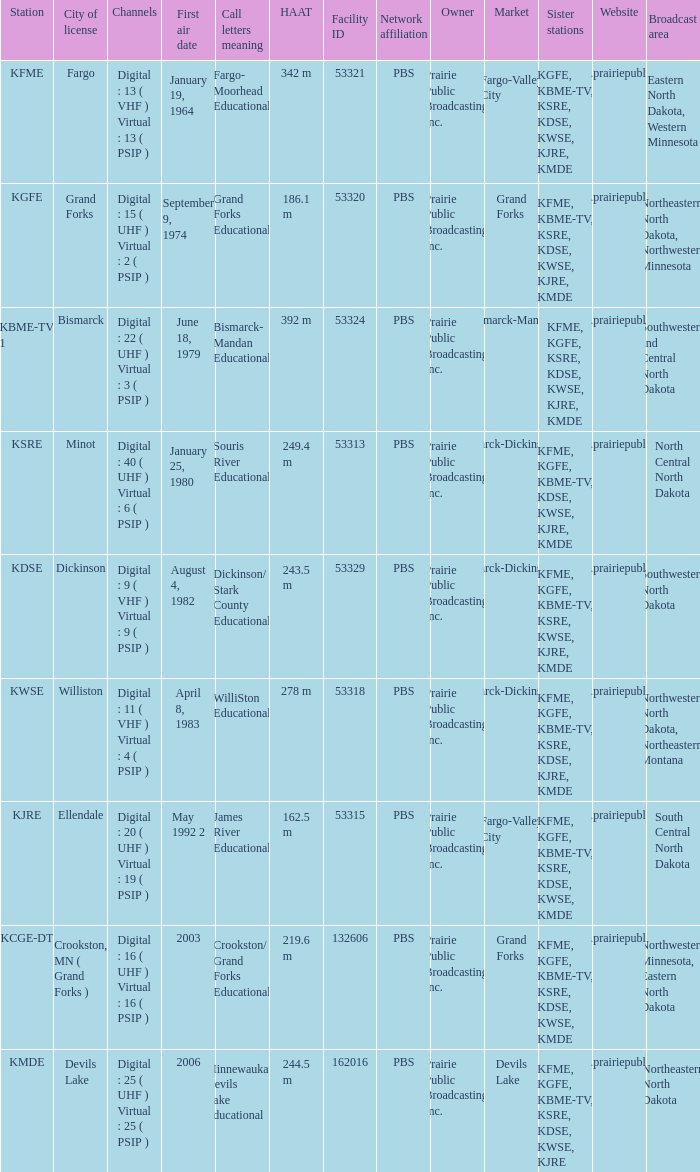What is the haat of devils lake 244.5 m. Give me the full table as a dictionary. {'header': ['Station', 'City of license', 'Channels', 'First air date', 'Call letters meaning', 'HAAT', 'Facility ID', 'Network affiliation', 'Owner', 'Market', 'Sister stations', 'Website', 'Broadcast area'], 'rows': [['KFME', 'Fargo', 'Digital : 13 ( VHF ) Virtual : 13 ( PSIP )', 'January 19, 1964', 'Fargo- Moorhead Educational', '342 m', '53321', 'PBS', 'Prairie Public Broadcasting, Inc.', 'Fargo-Valley City', 'KGFE, KBME-TV, KSRE, KDSE, KWSE, KJRE, KMDE', 'www.prairiepublic.org', 'Eastern North Dakota, Western Minnesota'], ['KGFE', 'Grand Forks', 'Digital : 15 ( UHF ) Virtual : 2 ( PSIP )', 'September 9, 1974', 'Grand Forks Educational', '186.1 m', '53320', 'PBS', 'Prairie Public Broadcasting, Inc.', 'Grand Forks', 'KFME, KBME-TV, KSRE, KDSE, KWSE, KJRE, KMDE', 'www.prairiepublic.org', 'Northeastern North Dakota, Northwestern Minnesota'], ['KBME-TV 1', 'Bismarck', 'Digital : 22 ( UHF ) Virtual : 3 ( PSIP )', 'June 18, 1979', 'Bismarck- Mandan Educational', '392 m', '53324', 'PBS', 'Prairie Public Broadcasting, Inc.', 'Bismarck-Mandan', 'KFME, KGFE, KSRE, KDSE, KWSE, KJRE, KMDE', 'www.prairiepublic.org', 'Southwestern and Central North Dakota'], ['KSRE', 'Minot', 'Digital : 40 ( UHF ) Virtual : 6 ( PSIP )', 'January 25, 1980', 'Souris River Educational', '249.4 m', '53313', 'PBS', 'Prairie Public Broadcasting, Inc.', 'Minot-Bismarck-Dickinson-Williston', 'KFME, KGFE, KBME-TV, KDSE, KWSE, KJRE, KMDE', 'www.prairiepublic.org', 'North Central North Dakota'], ['KDSE', 'Dickinson', 'Digital : 9 ( VHF ) Virtual : 9 ( PSIP )', 'August 4, 1982', 'Dickinson/ Stark County Educational', '243.5 m', '53329', 'PBS', 'Prairie Public Broadcasting, Inc.', 'Minot-Bismarck-Dickinson-Williston', 'KFME, KGFE, KBME-TV, KSRE, KWSE, KJRE, KMDE', 'www.prairiepublic.org', 'Southwestern North Dakota'], ['KWSE', 'Williston', 'Digital : 11 ( VHF ) Virtual : 4 ( PSIP )', 'April 8, 1983', 'WilliSton Educational', '278 m', '53318', 'PBS', 'Prairie Public Broadcasting, Inc.', 'Minot-Bismarck-Dickinson-Williston', 'KFME, KGFE, KBME-TV, KSRE, KDSE, KJRE, KMDE', 'www.prairiepublic.org', 'Northwestern North Dakota, Northeastern Montana'], ['KJRE', 'Ellendale', 'Digital : 20 ( UHF ) Virtual : 19 ( PSIP )', 'May 1992 2', 'James River Educational', '162.5 m', '53315', 'PBS', 'Prairie Public Broadcasting, Inc.', 'Fargo-Valley City', 'KFME, KGFE, KBME-TV, KSRE, KDSE, KWSE, KMDE', 'www.prairiepublic.org', 'South Central North Dakota'], ['KCGE-DT', 'Crookston, MN ( Grand Forks )', 'Digital : 16 ( UHF ) Virtual : 16 ( PSIP )', '2003', 'Crookston/ Grand Forks Educational', '219.6 m', '132606', 'PBS', 'Prairie Public Broadcasting, Inc.', 'Grand Forks', 'KFME, KGFE, KBME-TV, KSRE, KDSE, KWSE, KMDE', 'www.prairiepublic.org', 'Northwestern Minnesota, Eastern North Dakota'], ['KMDE', 'Devils Lake', 'Digital : 25 ( UHF ) Virtual : 25 ( PSIP )', '2006', 'Minnewaukan- Devils Lake Educational', '244.5 m', '162016', 'PBS', 'Prairie Public Broadcasting, Inc.', 'Devils Lake', 'KFME, KGFE, KBME-TV, KSRE, KDSE, KWSE, KJRE', 'www.prairiepublic.org', 'Northeastern North Dakota']]} 